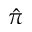Convert formula to latex. <formula><loc_0><loc_0><loc_500><loc_500>\hat { \pi }</formula> 